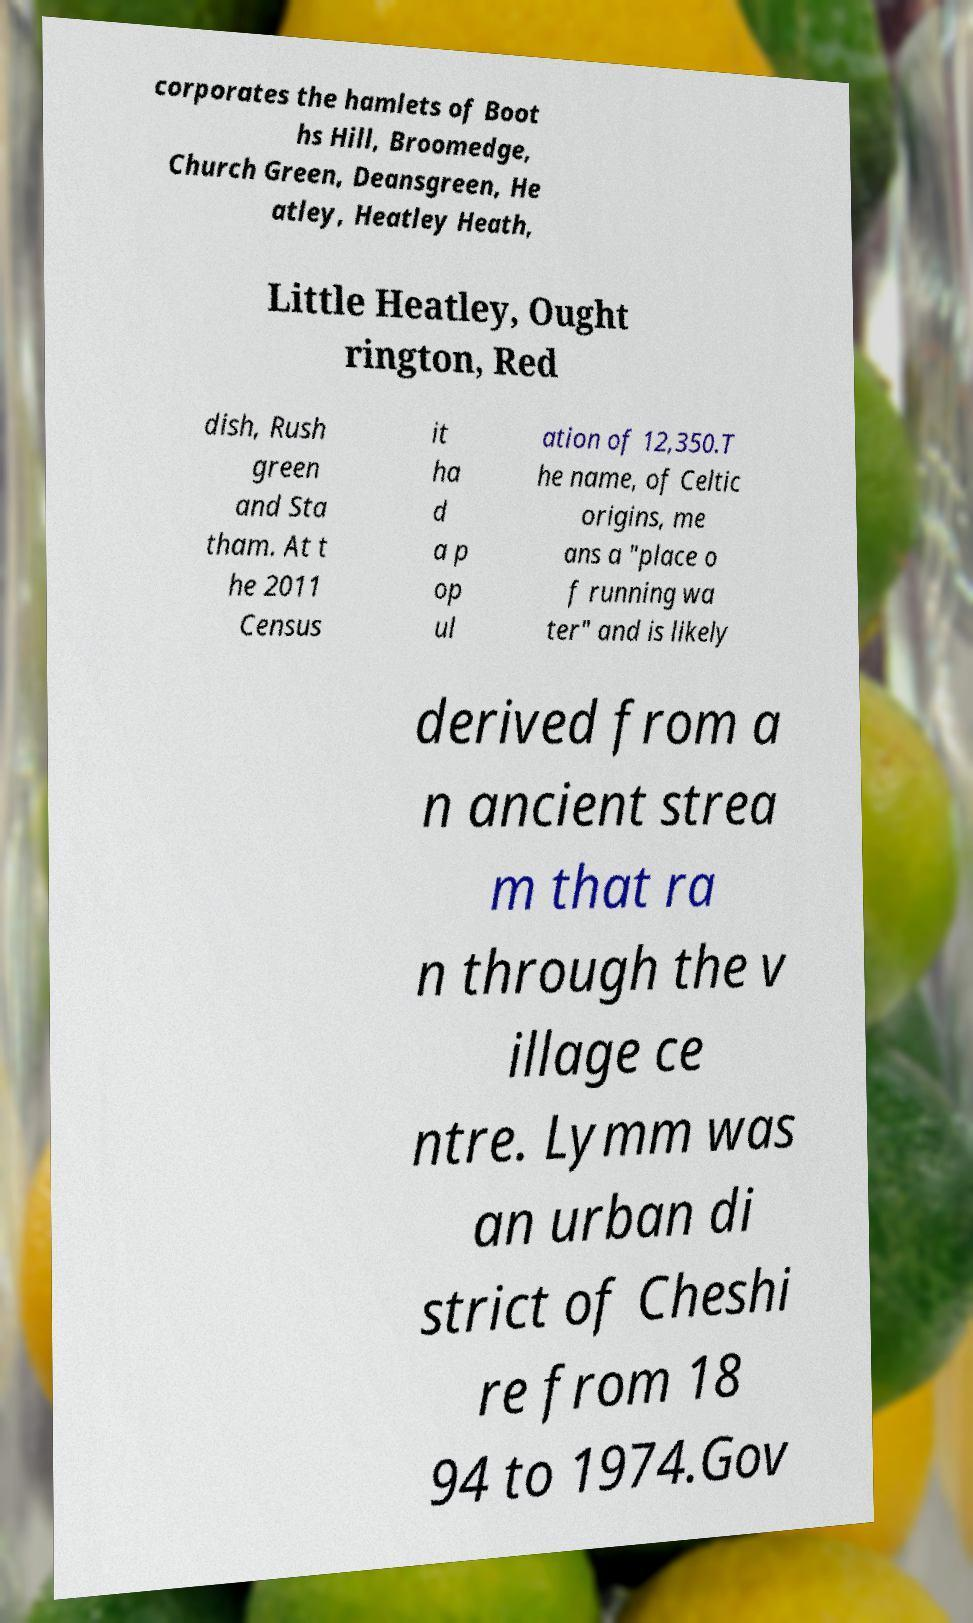Could you assist in decoding the text presented in this image and type it out clearly? corporates the hamlets of Boot hs Hill, Broomedge, Church Green, Deansgreen, He atley, Heatley Heath, Little Heatley, Ought rington, Red dish, Rush green and Sta tham. At t he 2011 Census it ha d a p op ul ation of 12,350.T he name, of Celtic origins, me ans a "place o f running wa ter" and is likely derived from a n ancient strea m that ra n through the v illage ce ntre. Lymm was an urban di strict of Cheshi re from 18 94 to 1974.Gov 